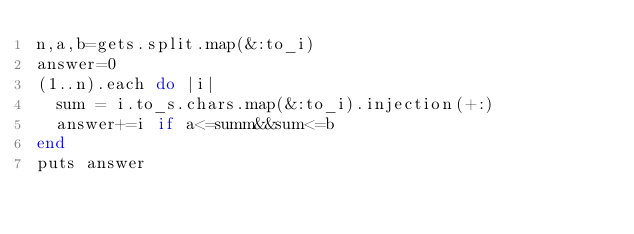<code> <loc_0><loc_0><loc_500><loc_500><_Ruby_>n,a,b=gets.split.map(&:to_i)
answer=0
(1..n).each do |i|
  sum = i.to_s.chars.map(&:to_i).injection(+:)
  answer+=i if a<=summ&&sum<=b
end
puts answer</code> 